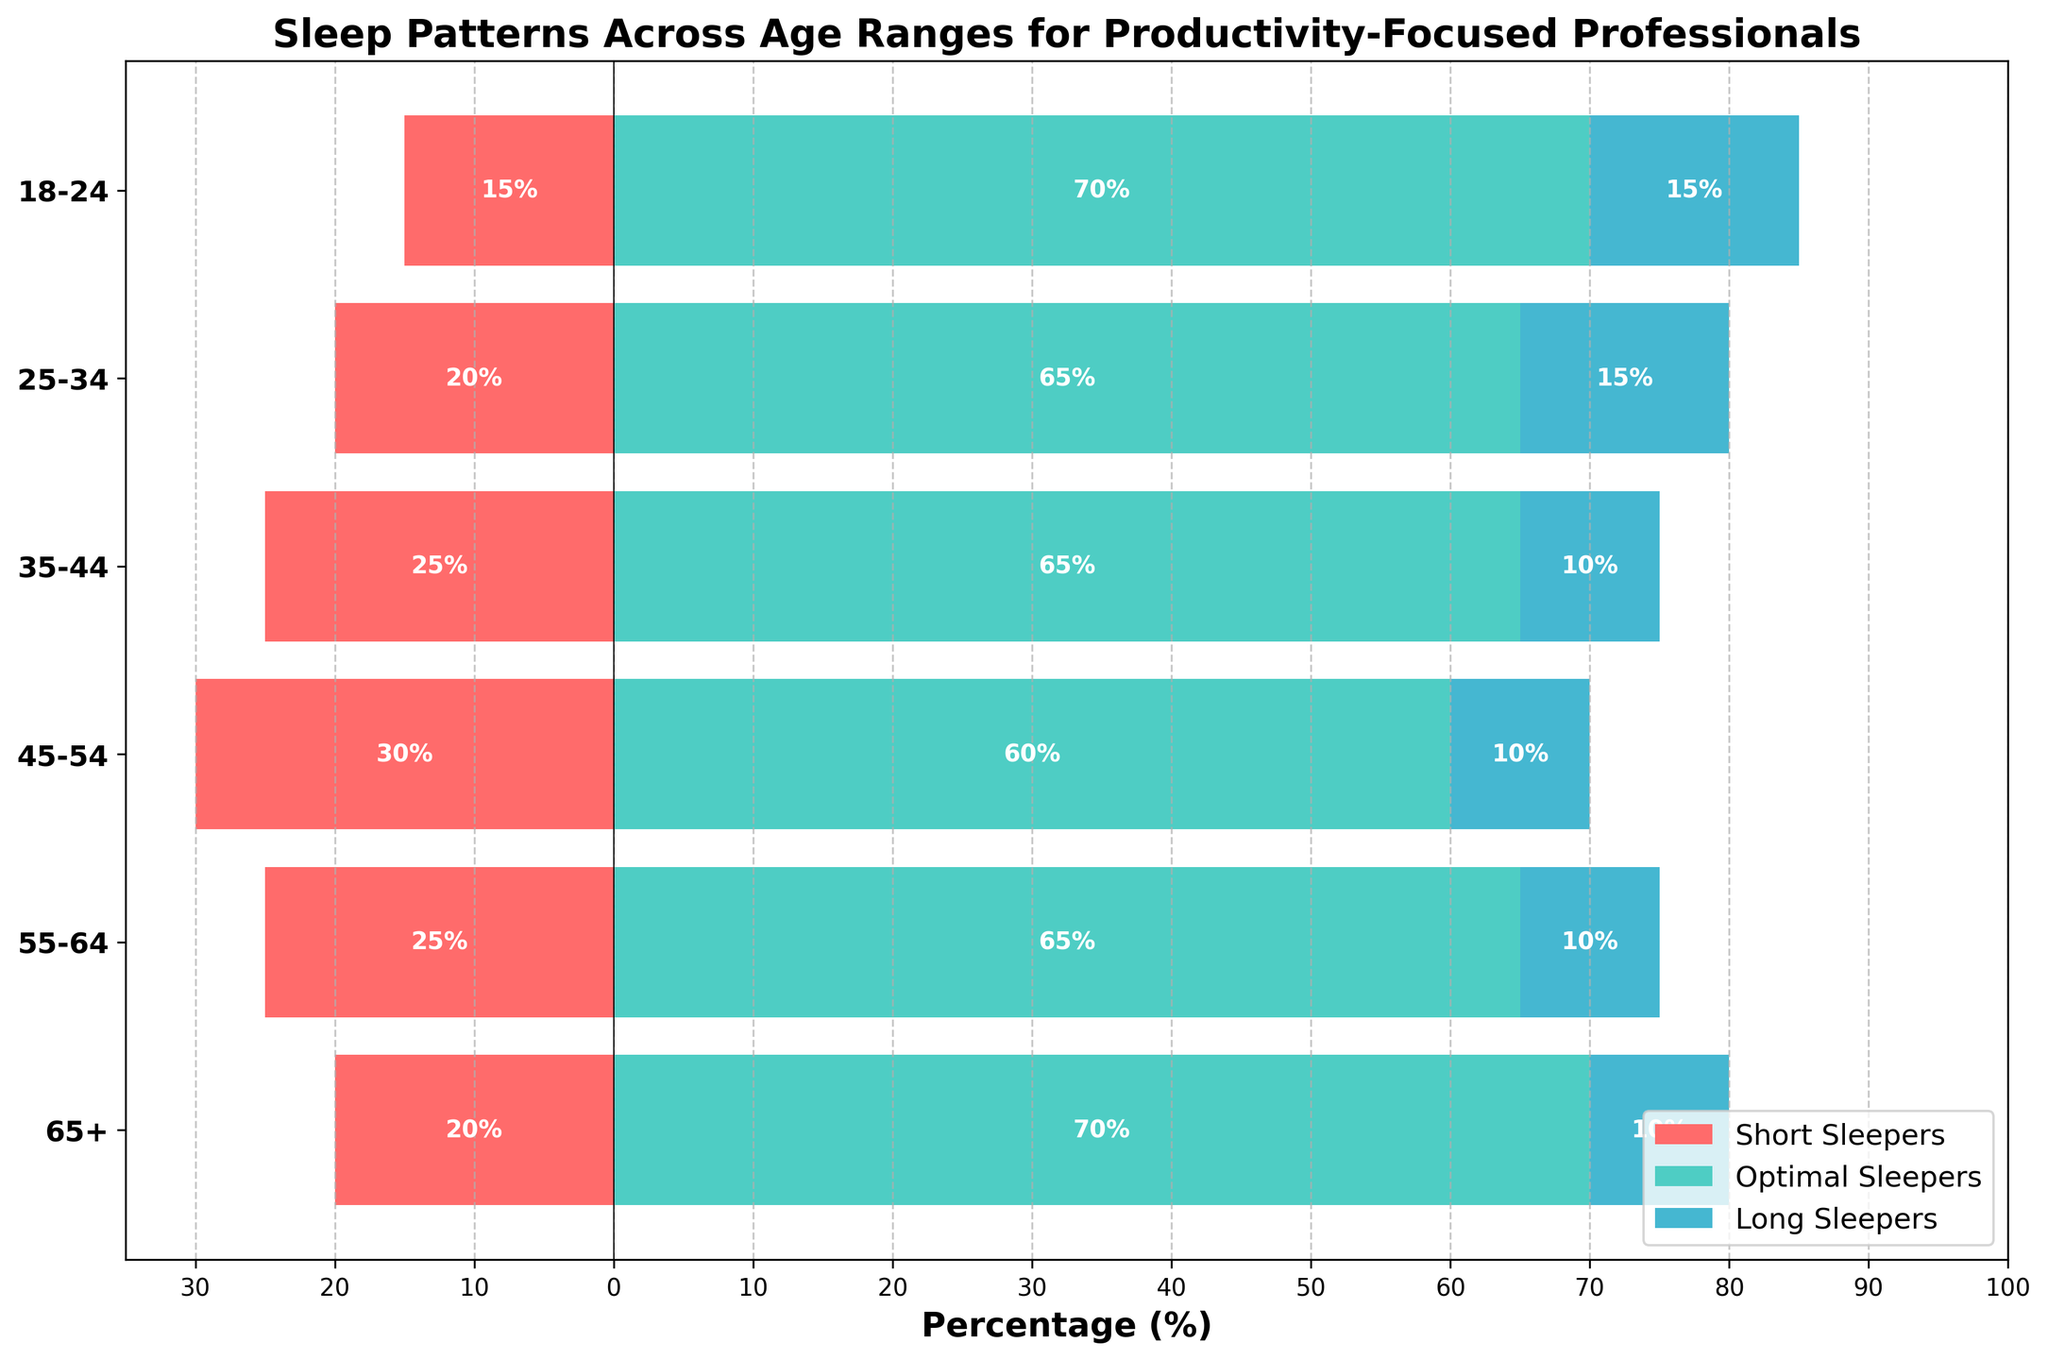What is the title of the figure? The figure title is typically placed at the top and summarizes what the visual represents. Here, it clearly shows that the title is "Sleep Patterns Across Age Ranges for Productivity-Focused Professionals."
Answer: Sleep Patterns Across Age Ranges for Productivity-Focused Professionals What are the three sleep categories shown in the figure? The different colors of the bars and the legend indicate the sleep categories. The categories are "Short Sleepers," "Optimal Sleepers," and "Long Sleepers."
Answer: Short Sleepers, Optimal Sleepers, Long Sleepers Which age range has the highest percentage of short sleepers? By examining the negative side of the x-axis where the "Short Sleepers" are represented in red, the age range with the longest bar is 45-54. This bar extends to -30%.
Answer: 45-54 How many age ranges show a higher percentage for optimal sleepers compared to short sleepers? Compare the positive bars for "Optimal Sleepers" (green) on the right to the negative bars for "Short Sleepers" (red) on the left. Every age range shows a higher percentage for optimal sleepers.
Answer: 6 What is the combined percentage of long sleepers and optimal sleepers in the 18-24 age range? The percentage for optimal sleepers in the 18-24 age range is 70%, and for long sleepers, it is 15%. Adding these together gives 70% + 15% = 85%.
Answer: 85% Which age group has the smallest percentage difference between short sleepers and optimal sleepers? For each age range, calculate the absolute difference between the percentages of short sleepers and optimal sleepers. The smallest difference is observed in the 25-34 age group (65% - 20% = 45%).
Answer: 25-34 How does the percentage of short sleepers change from the 18-24 age range to the 45-54 age range? Examine the red bars for "Short Sleepers." The 18-24 age range has 15%, while the 45-54 age range has 30%. The change is 30% - 15% = 15%.
Answer: Increases by 15% Which age range has the highest percentage of optimal sleepers? By comparing the extent of the green bars across age ranges, the 65+ and 18-24 groups both have the highest percentage, which is 70%.
Answer: 65+ and 18-24 What percentage of professionals aged 55-64 are long sleepers? Check the blue bar for "Long Sleepers" in the 55-64 age range, which extends to 10%.
Answer: 10% How do the sleep patterns of professionals aged 35-44 compare to those aged 65+? For 35-44, the percentages are 25% short sleepers, 65% optimal sleepers, and 10% long sleepers. For 65+, they are 20% short sleepers, 70% optimal sleepers, and 10% long sleepers. The primary difference is a higher percentage of optimal sleepers and a lower percentage of short sleepers in the 65+ group.
Answer: 35-44: 25% short, 65% optimal, 10% long; 65+: 20% short, 70% optimal, 10% long 